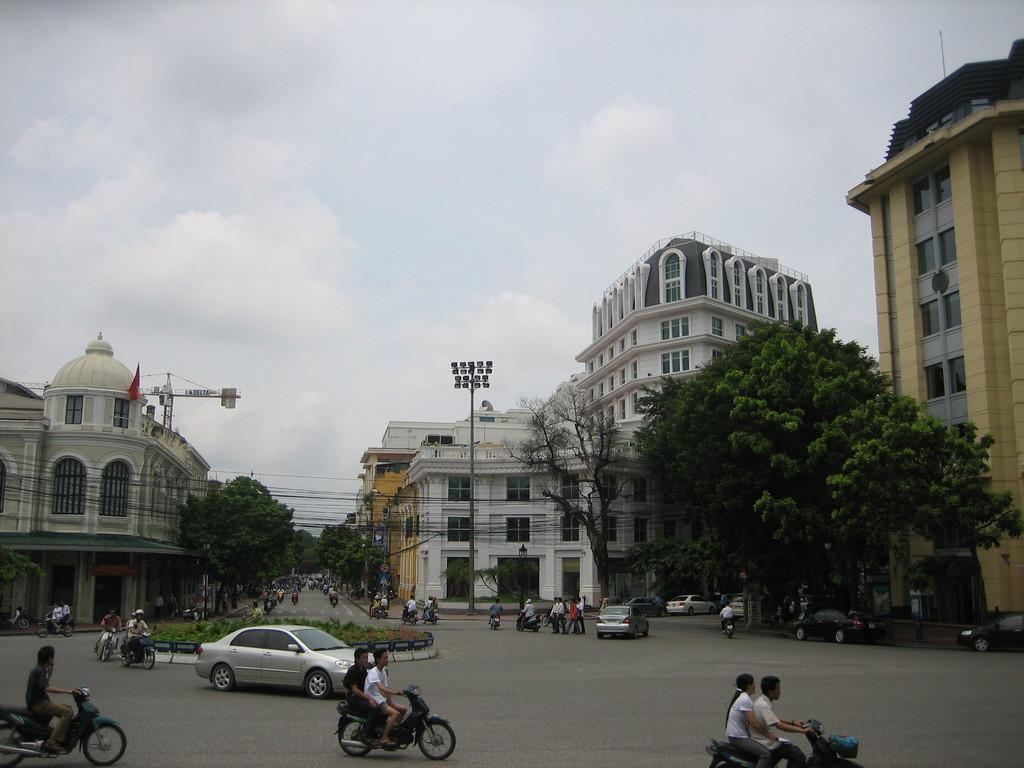What are the people in the image doing? The people in the image are riding vehicles on the road. What types of vehicles can be seen in the image? There are cars and bikes in the image. What can be seen in the background of the image? There are trees, buildings, a pole, and a light in the background of the image. How would you describe the weather in the image? The sky is cloudy in the image. Can you tell me how many stars are visible in the image? There are no stars visible in the image; the sky is cloudy. What type of wood is used to build the judge's bench in the image? There is no judge or bench present in the image. 